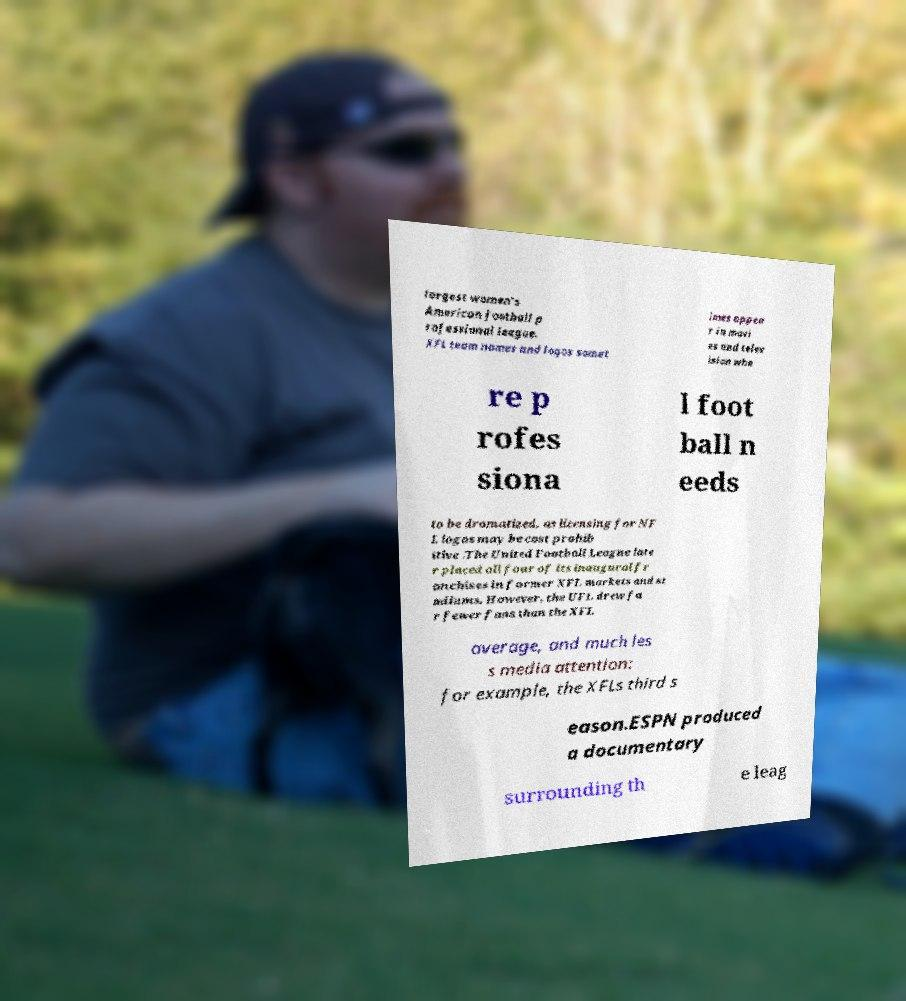Could you assist in decoding the text presented in this image and type it out clearly? largest women's American football p rofessional league. XFL team names and logos somet imes appea r in movi es and telev ision whe re p rofes siona l foot ball n eeds to be dramatized, as licensing for NF L logos may be cost prohib itive .The United Football League late r placed all four of its inaugural fr anchises in former XFL markets and st adiums. However, the UFL drew fa r fewer fans than the XFL average, and much les s media attention: for example, the XFLs third s eason.ESPN produced a documentary surrounding th e leag 